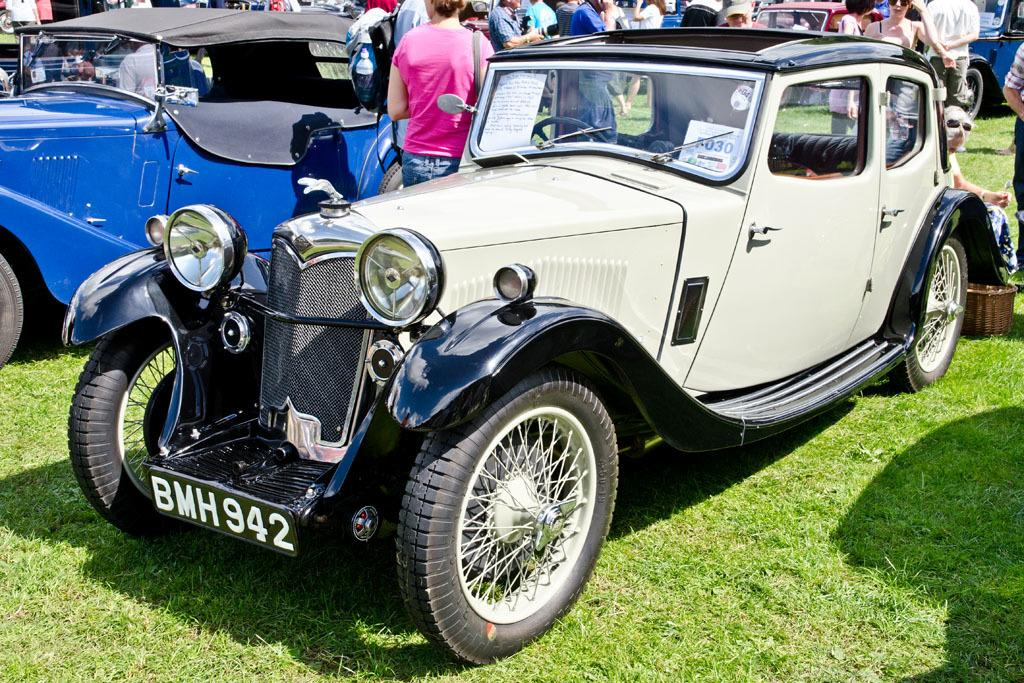What can be seen on the ground in the image? There are vehicles on the ground in the image. What is happening in the background of the image? There are people in the background of the image, and they are carrying bags on their shoulders. Can you describe an object on the right side of the image? There is a basket on the ground on the right side of the image. What type of hammer is being used by the goat in the image? There is no goat or hammer present in the image. Is the tin visible in the image being used as a toy by the people in the background? There is no tin present in the image. 